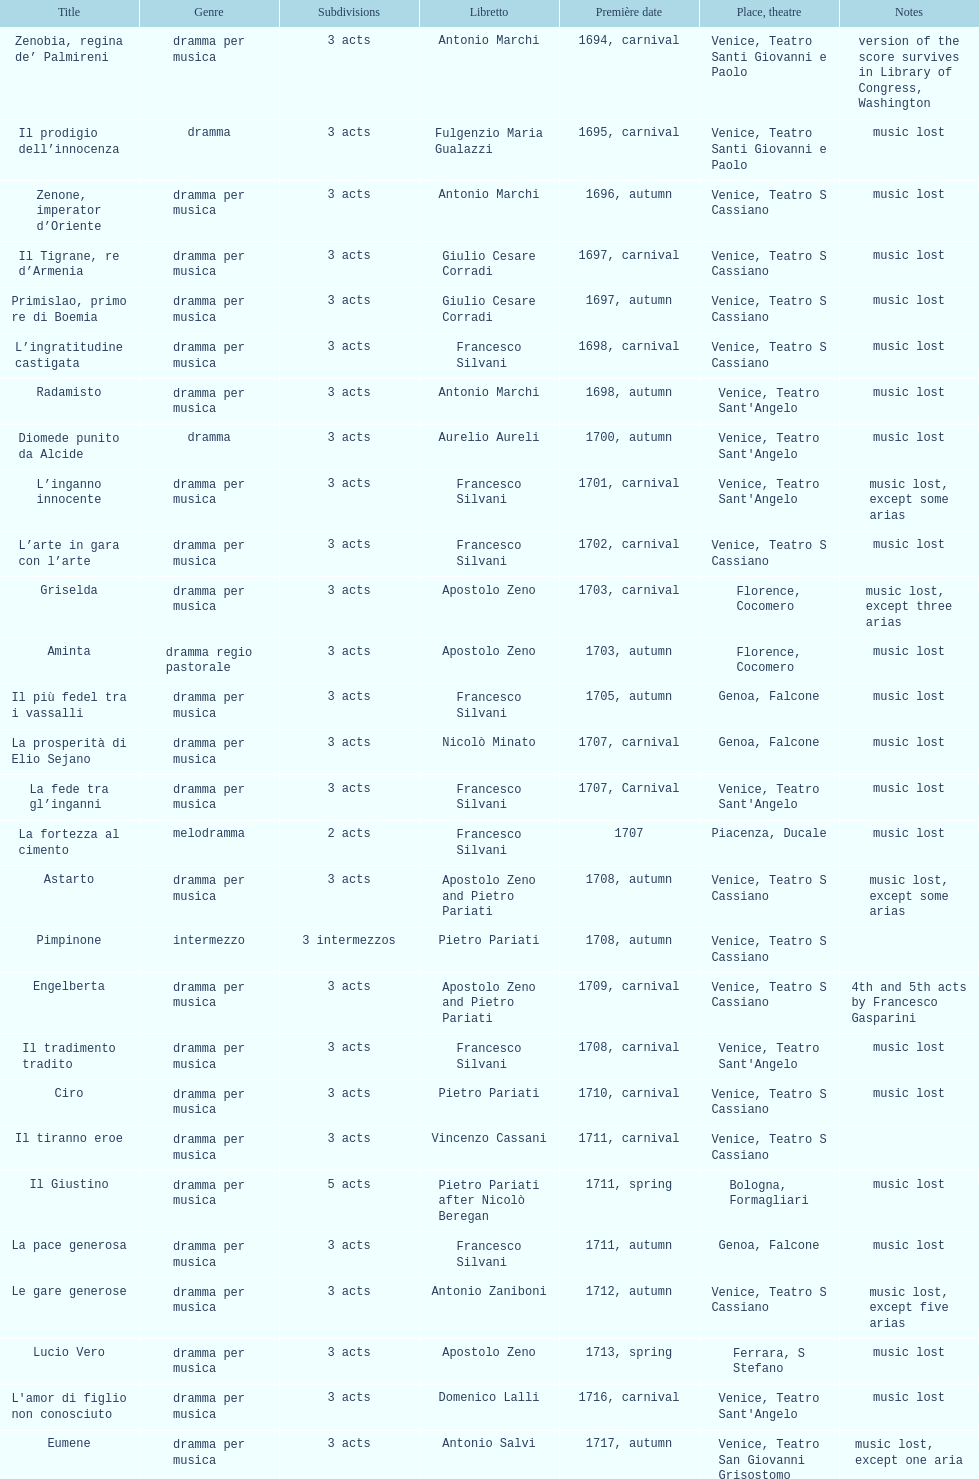What comes after ardelinda? Candalide. I'm looking to parse the entire table for insights. Could you assist me with that? {'header': ['Title', 'Genre', 'Sub\xaddivisions', 'Libretto', 'Première date', 'Place, theatre', 'Notes'], 'rows': [['Zenobia, regina de’ Palmireni', 'dramma per musica', '3 acts', 'Antonio Marchi', '1694, carnival', 'Venice, Teatro Santi Giovanni e Paolo', 'version of the score survives in Library of Congress, Washington'], ['Il prodigio dell’innocenza', 'dramma', '3 acts', 'Fulgenzio Maria Gualazzi', '1695, carnival', 'Venice, Teatro Santi Giovanni e Paolo', 'music lost'], ['Zenone, imperator d’Oriente', 'dramma per musica', '3 acts', 'Antonio Marchi', '1696, autumn', 'Venice, Teatro S Cassiano', 'music lost'], ['Il Tigrane, re d’Armenia', 'dramma per musica', '3 acts', 'Giulio Cesare Corradi', '1697, carnival', 'Venice, Teatro S Cassiano', 'music lost'], ['Primislao, primo re di Boemia', 'dramma per musica', '3 acts', 'Giulio Cesare Corradi', '1697, autumn', 'Venice, Teatro S Cassiano', 'music lost'], ['L’ingratitudine castigata', 'dramma per musica', '3 acts', 'Francesco Silvani', '1698, carnival', 'Venice, Teatro S Cassiano', 'music lost'], ['Radamisto', 'dramma per musica', '3 acts', 'Antonio Marchi', '1698, autumn', "Venice, Teatro Sant'Angelo", 'music lost'], ['Diomede punito da Alcide', 'dramma', '3 acts', 'Aurelio Aureli', '1700, autumn', "Venice, Teatro Sant'Angelo", 'music lost'], ['L’inganno innocente', 'dramma per musica', '3 acts', 'Francesco Silvani', '1701, carnival', "Venice, Teatro Sant'Angelo", 'music lost, except some arias'], ['L’arte in gara con l’arte', 'dramma per musica', '3 acts', 'Francesco Silvani', '1702, carnival', 'Venice, Teatro S Cassiano', 'music lost'], ['Griselda', 'dramma per musica', '3 acts', 'Apostolo Zeno', '1703, carnival', 'Florence, Cocomero', 'music lost, except three arias'], ['Aminta', 'dramma regio pastorale', '3 acts', 'Apostolo Zeno', '1703, autumn', 'Florence, Cocomero', 'music lost'], ['Il più fedel tra i vassalli', 'dramma per musica', '3 acts', 'Francesco Silvani', '1705, autumn', 'Genoa, Falcone', 'music lost'], ['La prosperità di Elio Sejano', 'dramma per musica', '3 acts', 'Nicolò Minato', '1707, carnival', 'Genoa, Falcone', 'music lost'], ['La fede tra gl’inganni', 'dramma per musica', '3 acts', 'Francesco Silvani', '1707, Carnival', "Venice, Teatro Sant'Angelo", 'music lost'], ['La fortezza al cimento', 'melodramma', '2 acts', 'Francesco Silvani', '1707', 'Piacenza, Ducale', 'music lost'], ['Astarto', 'dramma per musica', '3 acts', 'Apostolo Zeno and Pietro Pariati', '1708, autumn', 'Venice, Teatro S Cassiano', 'music lost, except some arias'], ['Pimpinone', 'intermezzo', '3 intermezzos', 'Pietro Pariati', '1708, autumn', 'Venice, Teatro S Cassiano', ''], ['Engelberta', 'dramma per musica', '3 acts', 'Apostolo Zeno and Pietro Pariati', '1709, carnival', 'Venice, Teatro S Cassiano', '4th and 5th acts by Francesco Gasparini'], ['Il tradimento tradito', 'dramma per musica', '3 acts', 'Francesco Silvani', '1708, carnival', "Venice, Teatro Sant'Angelo", 'music lost'], ['Ciro', 'dramma per musica', '3 acts', 'Pietro Pariati', '1710, carnival', 'Venice, Teatro S Cassiano', 'music lost'], ['Il tiranno eroe', 'dramma per musica', '3 acts', 'Vincenzo Cassani', '1711, carnival', 'Venice, Teatro S Cassiano', ''], ['Il Giustino', 'dramma per musica', '5 acts', 'Pietro Pariati after Nicolò Beregan', '1711, spring', 'Bologna, Formagliari', 'music lost'], ['La pace generosa', 'dramma per musica', '3 acts', 'Francesco Silvani', '1711, autumn', 'Genoa, Falcone', 'music lost'], ['Le gare generose', 'dramma per musica', '3 acts', 'Antonio Zaniboni', '1712, autumn', 'Venice, Teatro S Cassiano', 'music lost, except five arias'], ['Lucio Vero', 'dramma per musica', '3 acts', 'Apostolo Zeno', '1713, spring', 'Ferrara, S Stefano', 'music lost'], ["L'amor di figlio non conosciuto", 'dramma per musica', '3 acts', 'Domenico Lalli', '1716, carnival', "Venice, Teatro Sant'Angelo", 'music lost'], ['Eumene', 'dramma per musica', '3 acts', 'Antonio Salvi', '1717, autumn', 'Venice, Teatro San Giovanni Grisostomo', 'music lost, except one aria'], ['Meleagro', 'dramma per musica', '3 acts', 'Pietro Antonio Bernardoni', '1718, carnival', "Venice, Teatro Sant'Angelo", 'music lost'], ['Cleomene', 'dramma per musica', '3 acts', 'Vincenzo Cassani', '1718, carnival', "Venice, Teatro Sant'Angelo", 'music lost'], ['Gli eccessi della gelosia', 'dramma per musica', '3 acts', 'Domenico Lalli', '1722, carnival', "Venice, Teatro Sant'Angelo", 'music lost, except some arias'], ['I veri amici', 'dramma per musica', '3 acts', 'Francesco Silvani and Domenico Lalli after Pierre Corneille', '1722, October', 'Munich, Hof', 'music lost, except some arias'], ['Il trionfo d’amore', 'dramma per musica', '3 acts', 'Pietro Pariati', '1722, November', 'Munich', 'music lost'], ['Eumene', 'dramma per musica', '3 acts', 'Apostolo Zeno', '1723, carnival', 'Venice, Teatro San Moisè', 'music lost, except 2 arias'], ['Ermengarda', 'dramma per musica', '3 acts', 'Antonio Maria Lucchini', '1723, autumn', 'Venice, Teatro San Moisè', 'music lost'], ['Antigono, tutore di Filippo, re di Macedonia', 'tragedia', '5 acts', 'Giovanni Piazzon', '1724, carnival', 'Venice, Teatro San Moisè', '5th act by Giovanni Porta, music lost'], ['Scipione nelle Spagne', 'dramma per musica', '3 acts', 'Apostolo Zeno', '1724, Ascension', 'Venice, Teatro San Samuele', 'music lost'], ['Laodice', 'dramma per musica', '3 acts', 'Angelo Schietti', '1724, autumn', 'Venice, Teatro San Moisè', 'music lost, except 2 arias'], ['Didone abbandonata', 'tragedia', '3 acts', 'Metastasio', '1725, carnival', 'Venice, Teatro S Cassiano', 'music lost'], ["L'impresario delle Isole Canarie", 'intermezzo', '2 acts', 'Metastasio', '1725, carnival', 'Venice, Teatro S Cassiano', 'music lost'], ['Alcina delusa da Ruggero', 'dramma per musica', '3 acts', 'Antonio Marchi', '1725, autumn', 'Venice, Teatro S Cassiano', 'music lost'], ['I rivali generosi', 'dramma per musica', '3 acts', 'Apostolo Zeno', '1725', 'Brescia, Nuovo', ''], ['La Statira', 'dramma per musica', '3 acts', 'Apostolo Zeno and Pietro Pariati', '1726, Carnival', 'Rome, Teatro Capranica', ''], ['Malsazio e Fiammetta', 'intermezzo', '', '', '1726, Carnival', 'Rome, Teatro Capranica', ''], ['Il trionfo di Armida', 'dramma per musica', '3 acts', 'Girolamo Colatelli after Torquato Tasso', '1726, autumn', 'Venice, Teatro San Moisè', 'music lost'], ['L’incostanza schernita', 'dramma comico-pastorale', '3 acts', 'Vincenzo Cassani', '1727, Ascension', 'Venice, Teatro San Samuele', 'music lost, except some arias'], ['Le due rivali in amore', 'dramma per musica', '3 acts', 'Aurelio Aureli', '1728, autumn', 'Venice, Teatro San Moisè', 'music lost'], ['Il Satrapone', 'intermezzo', '', 'Salvi', '1729', 'Parma, Omodeo', ''], ['Li stratagemmi amorosi', 'dramma per musica', '3 acts', 'F Passerini', '1730, carnival', 'Venice, Teatro San Moisè', 'music lost'], ['Elenia', 'dramma per musica', '3 acts', 'Luisa Bergalli', '1730, carnival', "Venice, Teatro Sant'Angelo", 'music lost'], ['Merope', 'dramma', '3 acts', 'Apostolo Zeno', '1731, autumn', 'Prague, Sporck Theater', 'mostly by Albinoni, music lost'], ['Il più infedel tra gli amanti', 'dramma per musica', '3 acts', 'Angelo Schietti', '1731, autumn', 'Treviso, Dolphin', 'music lost'], ['Ardelinda', 'dramma', '3 acts', 'Bartolomeo Vitturi', '1732, autumn', "Venice, Teatro Sant'Angelo", 'music lost, except five arias'], ['Candalide', 'dramma per musica', '3 acts', 'Bartolomeo Vitturi', '1734, carnival', "Venice, Teatro Sant'Angelo", 'music lost'], ['Artamene', 'dramma per musica', '3 acts', 'Bartolomeo Vitturi', '1741, carnival', "Venice, Teatro Sant'Angelo", 'music lost']]} 